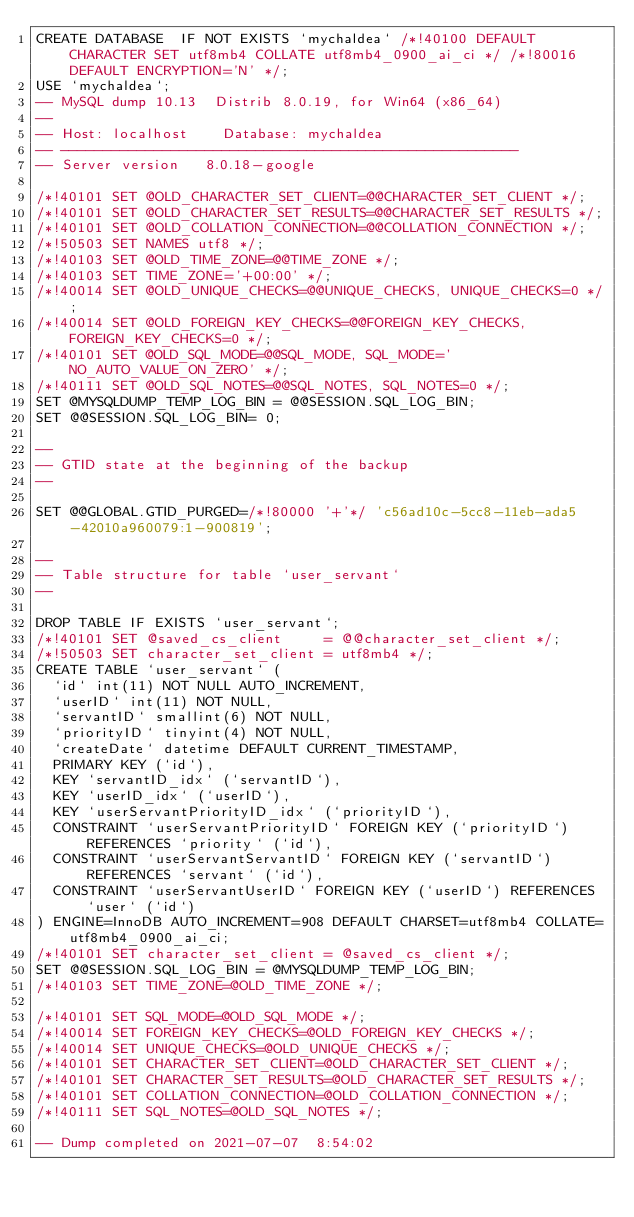Convert code to text. <code><loc_0><loc_0><loc_500><loc_500><_SQL_>CREATE DATABASE  IF NOT EXISTS `mychaldea` /*!40100 DEFAULT CHARACTER SET utf8mb4 COLLATE utf8mb4_0900_ai_ci */ /*!80016 DEFAULT ENCRYPTION='N' */;
USE `mychaldea`;
-- MySQL dump 10.13  Distrib 8.0.19, for Win64 (x86_64)
--
-- Host: localhost    Database: mychaldea
-- ------------------------------------------------------
-- Server version	8.0.18-google

/*!40101 SET @OLD_CHARACTER_SET_CLIENT=@@CHARACTER_SET_CLIENT */;
/*!40101 SET @OLD_CHARACTER_SET_RESULTS=@@CHARACTER_SET_RESULTS */;
/*!40101 SET @OLD_COLLATION_CONNECTION=@@COLLATION_CONNECTION */;
/*!50503 SET NAMES utf8 */;
/*!40103 SET @OLD_TIME_ZONE=@@TIME_ZONE */;
/*!40103 SET TIME_ZONE='+00:00' */;
/*!40014 SET @OLD_UNIQUE_CHECKS=@@UNIQUE_CHECKS, UNIQUE_CHECKS=0 */;
/*!40014 SET @OLD_FOREIGN_KEY_CHECKS=@@FOREIGN_KEY_CHECKS, FOREIGN_KEY_CHECKS=0 */;
/*!40101 SET @OLD_SQL_MODE=@@SQL_MODE, SQL_MODE='NO_AUTO_VALUE_ON_ZERO' */;
/*!40111 SET @OLD_SQL_NOTES=@@SQL_NOTES, SQL_NOTES=0 */;
SET @MYSQLDUMP_TEMP_LOG_BIN = @@SESSION.SQL_LOG_BIN;
SET @@SESSION.SQL_LOG_BIN= 0;

--
-- GTID state at the beginning of the backup 
--

SET @@GLOBAL.GTID_PURGED=/*!80000 '+'*/ 'c56ad10c-5cc8-11eb-ada5-42010a960079:1-900819';

--
-- Table structure for table `user_servant`
--

DROP TABLE IF EXISTS `user_servant`;
/*!40101 SET @saved_cs_client     = @@character_set_client */;
/*!50503 SET character_set_client = utf8mb4 */;
CREATE TABLE `user_servant` (
  `id` int(11) NOT NULL AUTO_INCREMENT,
  `userID` int(11) NOT NULL,
  `servantID` smallint(6) NOT NULL,
  `priorityID` tinyint(4) NOT NULL,
  `createDate` datetime DEFAULT CURRENT_TIMESTAMP,
  PRIMARY KEY (`id`),
  KEY `servantID_idx` (`servantID`),
  KEY `userID_idx` (`userID`),
  KEY `userServantPriorityID_idx` (`priorityID`),
  CONSTRAINT `userServantPriorityID` FOREIGN KEY (`priorityID`) REFERENCES `priority` (`id`),
  CONSTRAINT `userServantServantID` FOREIGN KEY (`servantID`) REFERENCES `servant` (`id`),
  CONSTRAINT `userServantUserID` FOREIGN KEY (`userID`) REFERENCES `user` (`id`)
) ENGINE=InnoDB AUTO_INCREMENT=908 DEFAULT CHARSET=utf8mb4 COLLATE=utf8mb4_0900_ai_ci;
/*!40101 SET character_set_client = @saved_cs_client */;
SET @@SESSION.SQL_LOG_BIN = @MYSQLDUMP_TEMP_LOG_BIN;
/*!40103 SET TIME_ZONE=@OLD_TIME_ZONE */;

/*!40101 SET SQL_MODE=@OLD_SQL_MODE */;
/*!40014 SET FOREIGN_KEY_CHECKS=@OLD_FOREIGN_KEY_CHECKS */;
/*!40014 SET UNIQUE_CHECKS=@OLD_UNIQUE_CHECKS */;
/*!40101 SET CHARACTER_SET_CLIENT=@OLD_CHARACTER_SET_CLIENT */;
/*!40101 SET CHARACTER_SET_RESULTS=@OLD_CHARACTER_SET_RESULTS */;
/*!40101 SET COLLATION_CONNECTION=@OLD_COLLATION_CONNECTION */;
/*!40111 SET SQL_NOTES=@OLD_SQL_NOTES */;

-- Dump completed on 2021-07-07  8:54:02
</code> 